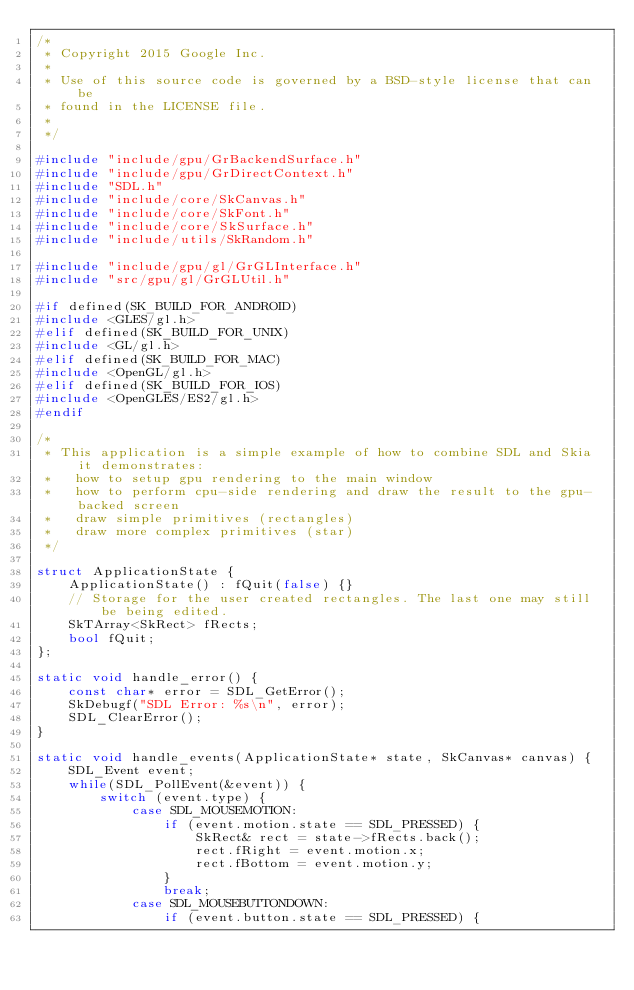<code> <loc_0><loc_0><loc_500><loc_500><_C++_>/*
 * Copyright 2015 Google Inc.
 *
 * Use of this source code is governed by a BSD-style license that can be
 * found in the LICENSE file.
 *
 */

#include "include/gpu/GrBackendSurface.h"
#include "include/gpu/GrDirectContext.h"
#include "SDL.h"
#include "include/core/SkCanvas.h"
#include "include/core/SkFont.h"
#include "include/core/SkSurface.h"
#include "include/utils/SkRandom.h"

#include "include/gpu/gl/GrGLInterface.h"
#include "src/gpu/gl/GrGLUtil.h"

#if defined(SK_BUILD_FOR_ANDROID)
#include <GLES/gl.h>
#elif defined(SK_BUILD_FOR_UNIX)
#include <GL/gl.h>
#elif defined(SK_BUILD_FOR_MAC)
#include <OpenGL/gl.h>
#elif defined(SK_BUILD_FOR_IOS)
#include <OpenGLES/ES2/gl.h>
#endif

/*
 * This application is a simple example of how to combine SDL and Skia it demonstrates:
 *   how to setup gpu rendering to the main window
 *   how to perform cpu-side rendering and draw the result to the gpu-backed screen
 *   draw simple primitives (rectangles)
 *   draw more complex primitives (star)
 */

struct ApplicationState {
    ApplicationState() : fQuit(false) {}
    // Storage for the user created rectangles. The last one may still be being edited.
    SkTArray<SkRect> fRects;
    bool fQuit;
};

static void handle_error() {
    const char* error = SDL_GetError();
    SkDebugf("SDL Error: %s\n", error);
    SDL_ClearError();
}

static void handle_events(ApplicationState* state, SkCanvas* canvas) {
    SDL_Event event;
    while(SDL_PollEvent(&event)) {
        switch (event.type) {
            case SDL_MOUSEMOTION:
                if (event.motion.state == SDL_PRESSED) {
                    SkRect& rect = state->fRects.back();
                    rect.fRight = event.motion.x;
                    rect.fBottom = event.motion.y;
                }
                break;
            case SDL_MOUSEBUTTONDOWN:
                if (event.button.state == SDL_PRESSED) {</code> 